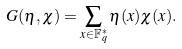<formula> <loc_0><loc_0><loc_500><loc_500>G ( \eta , \chi ) = \sum _ { x \in \mathbb { F } _ { q } ^ { * } } \eta ( x ) \chi ( x ) .</formula> 